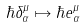Convert formula to latex. <formula><loc_0><loc_0><loc_500><loc_500>\hbar { \delta } ^ { \mu } _ { \alpha } \mapsto \hbar { e } ^ { \mu } _ { \alpha }</formula> 